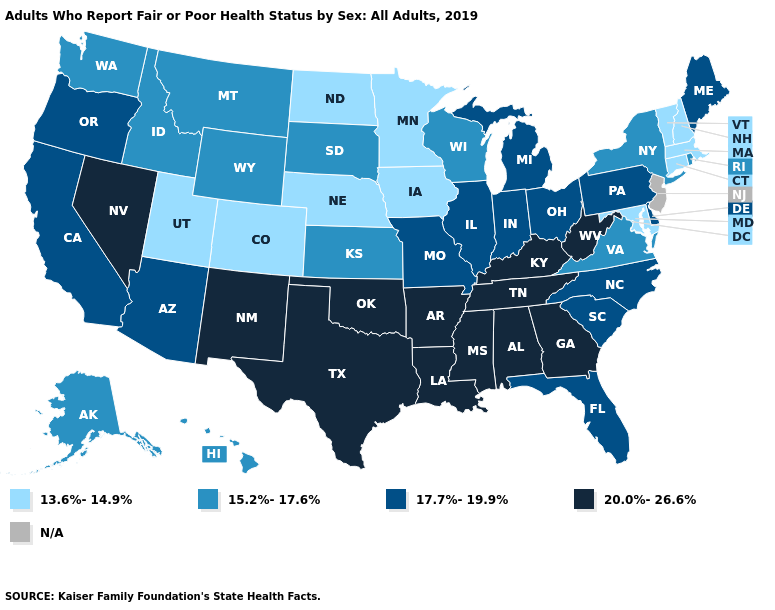Name the states that have a value in the range 15.2%-17.6%?
Short answer required. Alaska, Hawaii, Idaho, Kansas, Montana, New York, Rhode Island, South Dakota, Virginia, Washington, Wisconsin, Wyoming. What is the highest value in the South ?
Quick response, please. 20.0%-26.6%. What is the highest value in the West ?
Write a very short answer. 20.0%-26.6%. Among the states that border Florida , which have the highest value?
Answer briefly. Alabama, Georgia. Among the states that border South Carolina , which have the highest value?
Write a very short answer. Georgia. What is the value of Pennsylvania?
Short answer required. 17.7%-19.9%. Which states have the lowest value in the South?
Concise answer only. Maryland. Among the states that border Rhode Island , which have the highest value?
Give a very brief answer. Connecticut, Massachusetts. Does Oregon have the highest value in the West?
Write a very short answer. No. Name the states that have a value in the range N/A?
Concise answer only. New Jersey. Name the states that have a value in the range N/A?
Answer briefly. New Jersey. Name the states that have a value in the range 17.7%-19.9%?
Write a very short answer. Arizona, California, Delaware, Florida, Illinois, Indiana, Maine, Michigan, Missouri, North Carolina, Ohio, Oregon, Pennsylvania, South Carolina. Name the states that have a value in the range N/A?
Concise answer only. New Jersey. What is the highest value in states that border Florida?
Give a very brief answer. 20.0%-26.6%. 